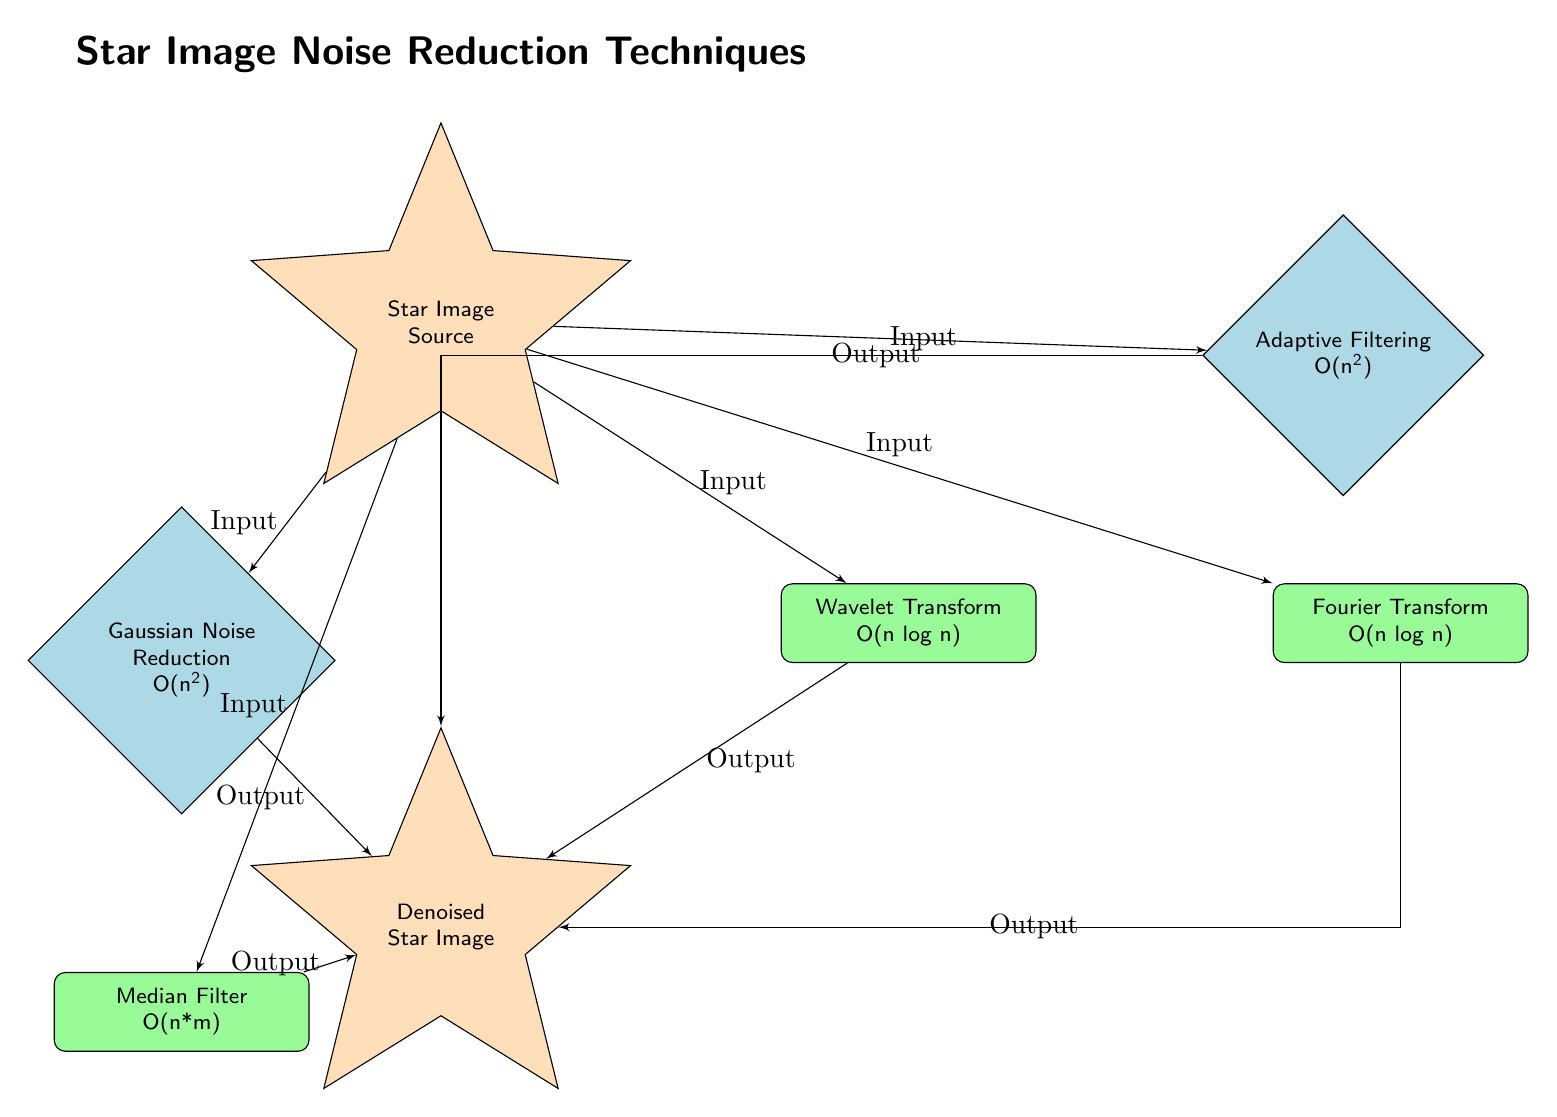What is the output after applying the Gaussian noise reduction technique? The Gaussian noise reduction technique processes the star image and outputs a denoised star image. Following the path from the Gaussian noise node to the denoised star image node, this is the only output indicated from that node.
Answer: Denoised Star Image What is the computational complexity of the median filter? The median filter is associated with a complexity of O(n*m) in the diagram. This is directly stated in the median filter node.
Answer: O(n*m) How many noise reduction techniques are listed in the diagram? The diagram includes five noise reduction techniques: Gaussian noise reduction, median filter, wavelet transform, Fourier transform, and adaptive filtering. By counting the nodes, we find that there are five.
Answer: Five Which technique has the lowest computational complexity? By examining the computational complexities listed, both the wavelet transform and Fourier transform have the lowest complexity of O(n log n), which is less than all other methods shown in the diagram.
Answer: O(n log n) What is the relationship between the source star image and the adaptive filtering process? The source star image acts as an input to the adaptive filtering process. The arrows in the diagram indicate this directional flow, where the input from the source node goes to the adaptive filtering node.
Answer: Input Which noise reduction method has a complexity of O(n squared)? The diagram specifies that both Gaussian noise reduction and adaptive filtering have a computational complexity denoted as O(n squared). This is apparent from the respective nodes showing their complexity.
Answer: O(n squared) How many output connections are there from the wavelet transform? The wavelet transform node has one output connection that leads to the denoised star image node. Traversing from the wavelet node to the output node highlights this singular path.
Answer: One Which technique is located closest to the source node? The Gaussian noise reduction technique is located directly below the source node. This placement indicates its position relative to the source, making it the one closest to it in the diagram.
Answer: Gaussian Noise Reduction 